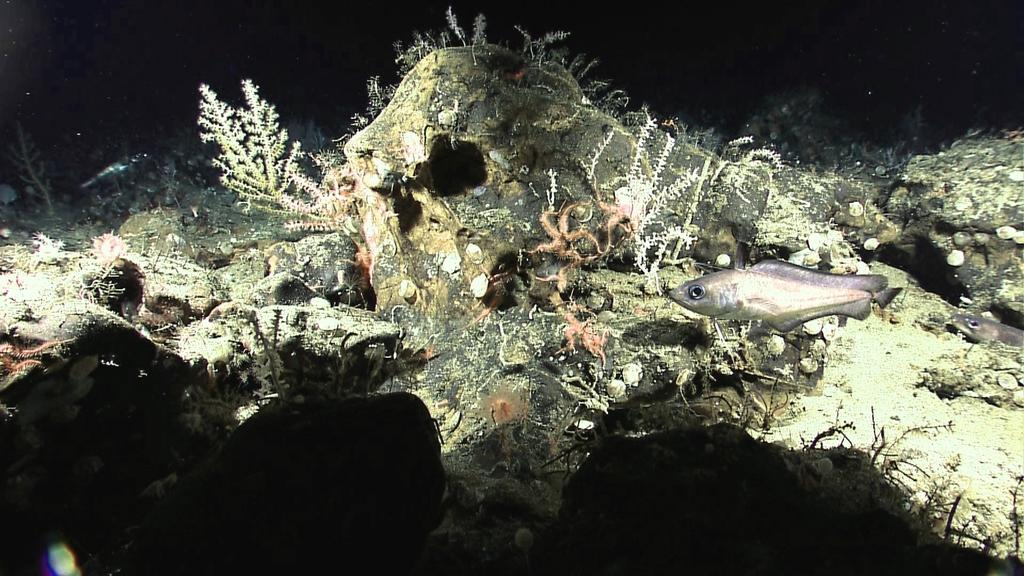What type of animals can be seen in the image? There are fishes in the water. What else can be seen in the water besides the fishes? There are marine plants in the water. What is the color of the background in the image? The background of the image is dark. What type of record can be seen in the image? There is no record present in the image; it features fishes and marine plants in the water. What type of cord is used to connect the fishes in the image? There is no cord connecting the fishes in the image; they are swimming freely in the water. 